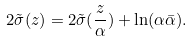<formula> <loc_0><loc_0><loc_500><loc_500>2 \tilde { \sigma } ( z ) = 2 \tilde { \sigma } ( \frac { z } { \alpha } ) + \ln ( \alpha \bar { \alpha } ) .</formula> 